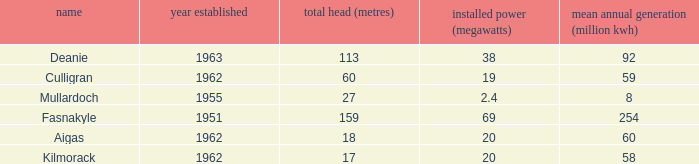What is the Year Commissioned of the power stationo with a Gross head of less than 18? 1962.0. 